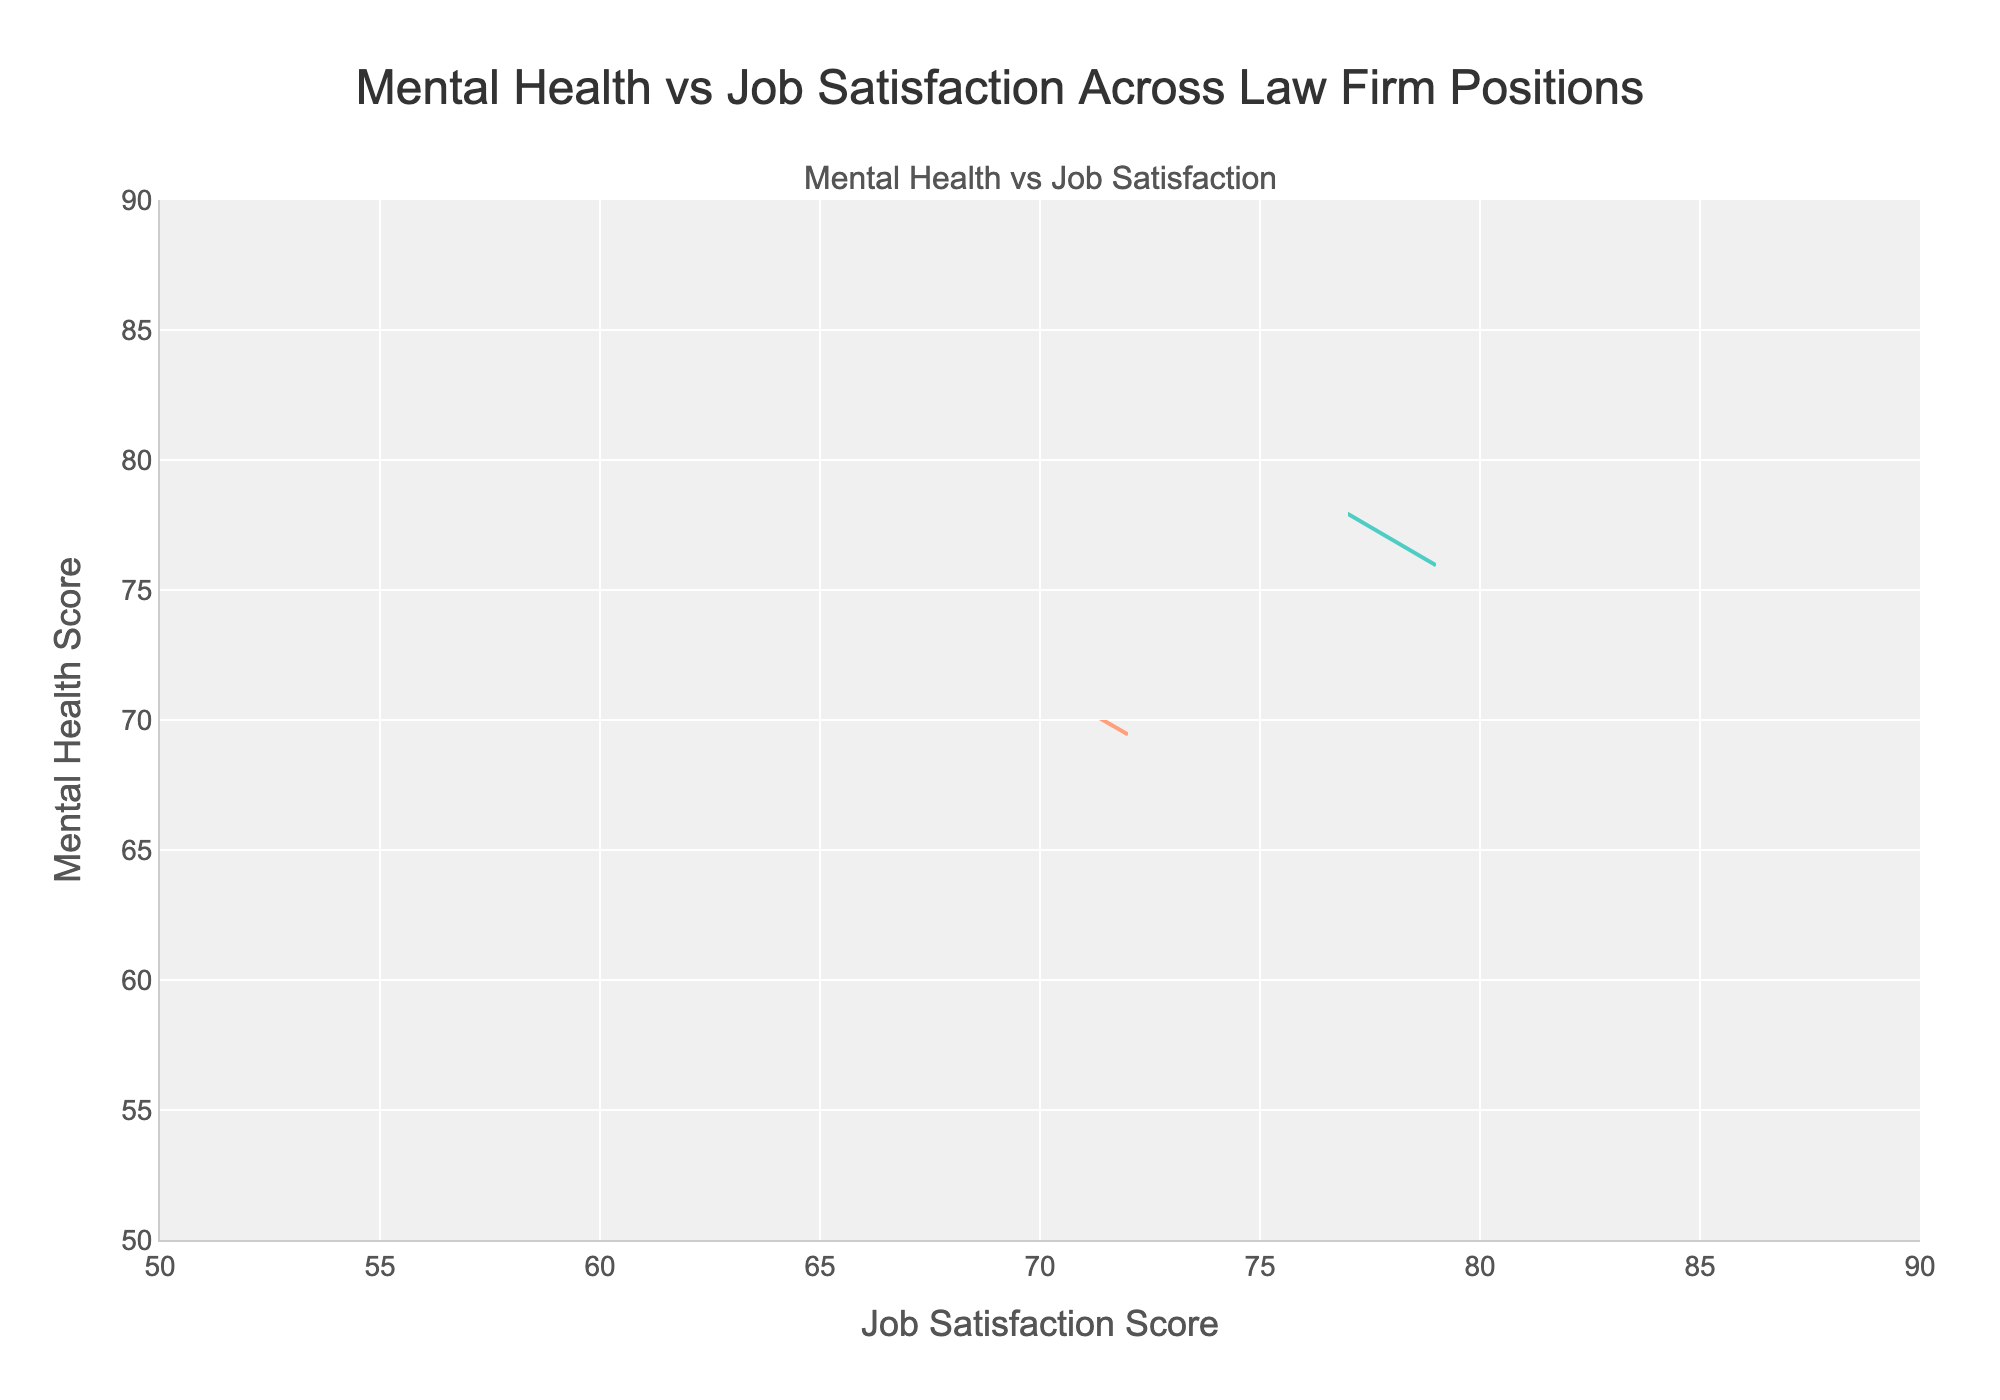What is the title of the figure? The title of the figure is displayed prominently at the top of the chart.
Answer: Mental Health vs Job Satisfaction Across Law Firm Positions What are the x-axis and y-axis titles? The x-axis and y-axis titles are labeled at the bottom and the left side of the chart respectively.
Answer: Job Satisfaction Score, Mental Health Score Which position shows the highest mental health scores? By looking at the data points and contours, the position with the highest mental health scores peaks at 88.
Answer: Partner Which position is represented by green-colored contours? The green color in the contour plots corresponds to one of the positions differentiated by unique colors.
Answer: Senior Associate Comparing Associates and Paralegals, which group exhibits higher job satisfaction scores on average? By comparing the centers of density for both groups, Associates have scores ranging from 58 to 66 while Paralegals have scores from 68 to 72. The average job satisfaction score of Associates is (60+62+58)/3 = 60, while for Paralegals it is (70+72+68)/3 ≈ 70.
Answer: Paralegals What is the relationship between mental health and job satisfaction for Legal Secretaries shown on the contour plot? Examining the shape and direction of the contour lines for Legal Secretaries, there is a general positive correlation as contours extend diagonally upwards.
Answer: Positive correlation How do mental health scores for Senior Associates compare to those for Partners? Senior Associates have mental health scores ranging from 74 to 78, while Partners have scores ranging from 85 to 88. So, Partners generally have higher mental health scores.
Answer: Higher for Partners Which group has the widest spread in mental health scores? Analyzing the vertical range of the contour plots indicates that Associates have the widest spread, from 58 to 62.
Answer: Associate Is there any group that shows close correlation between mental health and job satisfaction scores? Observing the contour density and proximity, Senior Associates show closely packed contours indicating a stronger correlation.
Answer: Senior Associate 